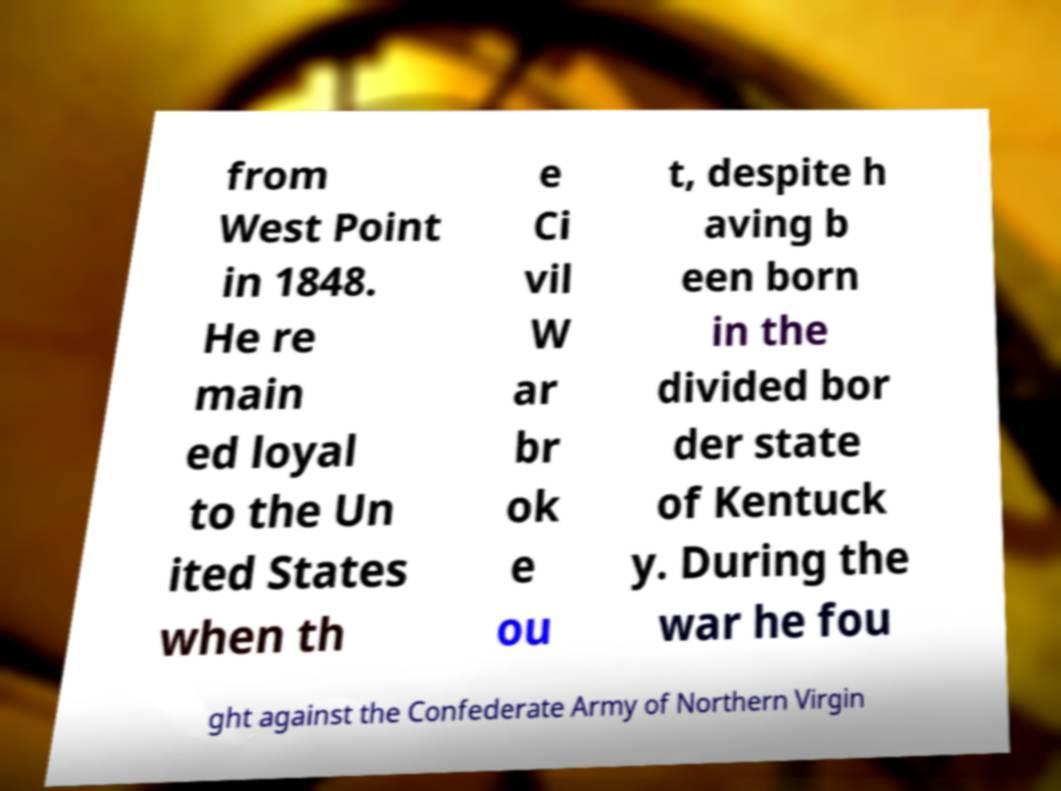Please read and relay the text visible in this image. What does it say? from West Point in 1848. He re main ed loyal to the Un ited States when th e Ci vil W ar br ok e ou t, despite h aving b een born in the divided bor der state of Kentuck y. During the war he fou ght against the Confederate Army of Northern Virgin 